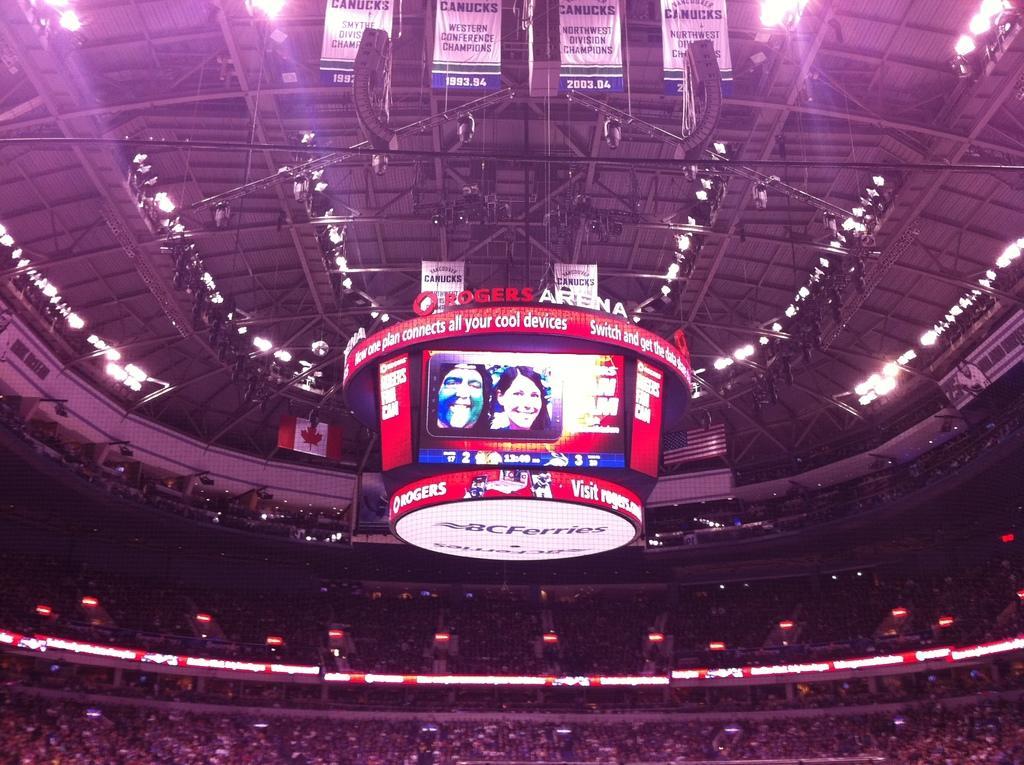Describe this image in one or two sentences. In this image I can see a crowd, fence, lights, boards, screen, hoardings, metal rods, rooftop, posters and so on. This image is taken may be during night. 